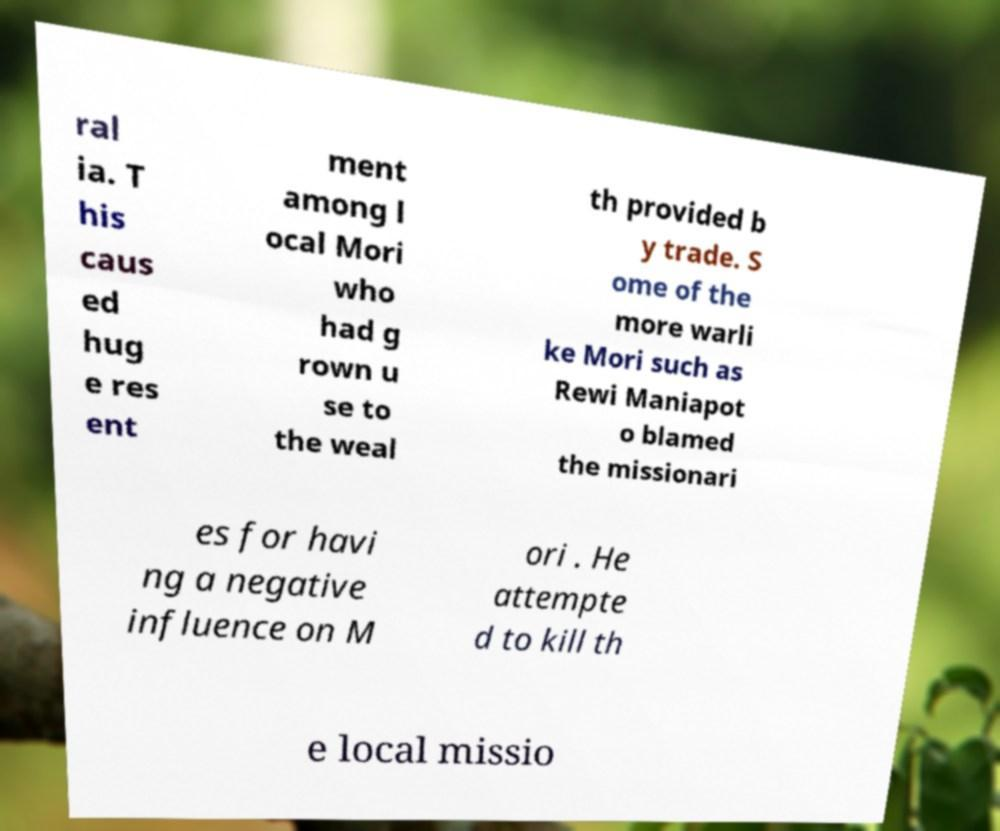Can you read and provide the text displayed in the image?This photo seems to have some interesting text. Can you extract and type it out for me? ral ia. T his caus ed hug e res ent ment among l ocal Mori who had g rown u se to the weal th provided b y trade. S ome of the more warli ke Mori such as Rewi Maniapot o blamed the missionari es for havi ng a negative influence on M ori . He attempte d to kill th e local missio 